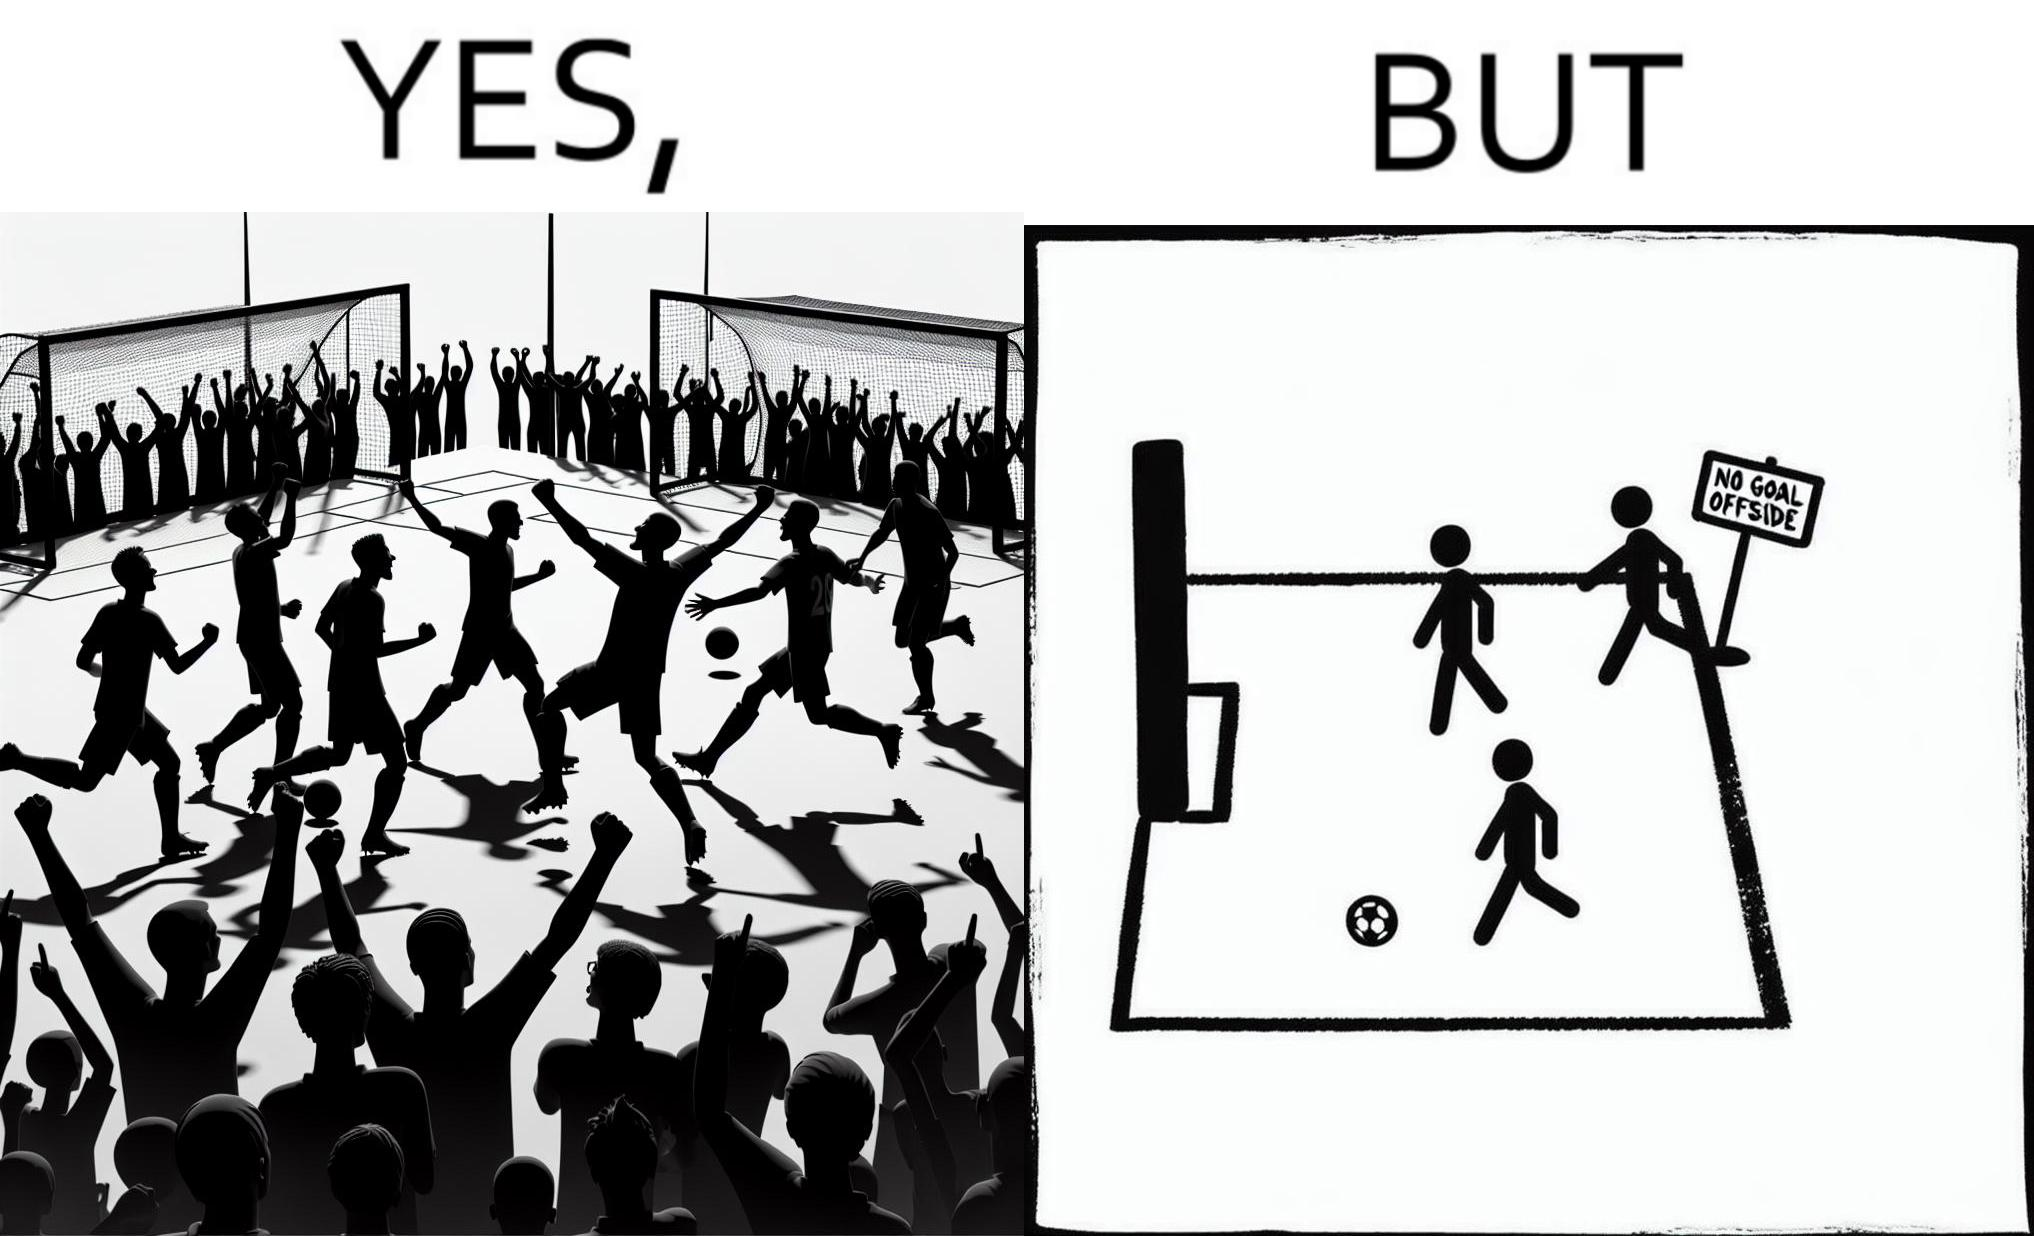What does this image depict? The image is ironical, as the team is celebrating as they think that they have scored a goal, but the sign on the screen says that it is an offside, and not a goal. This is a very common scenario in football matches. 